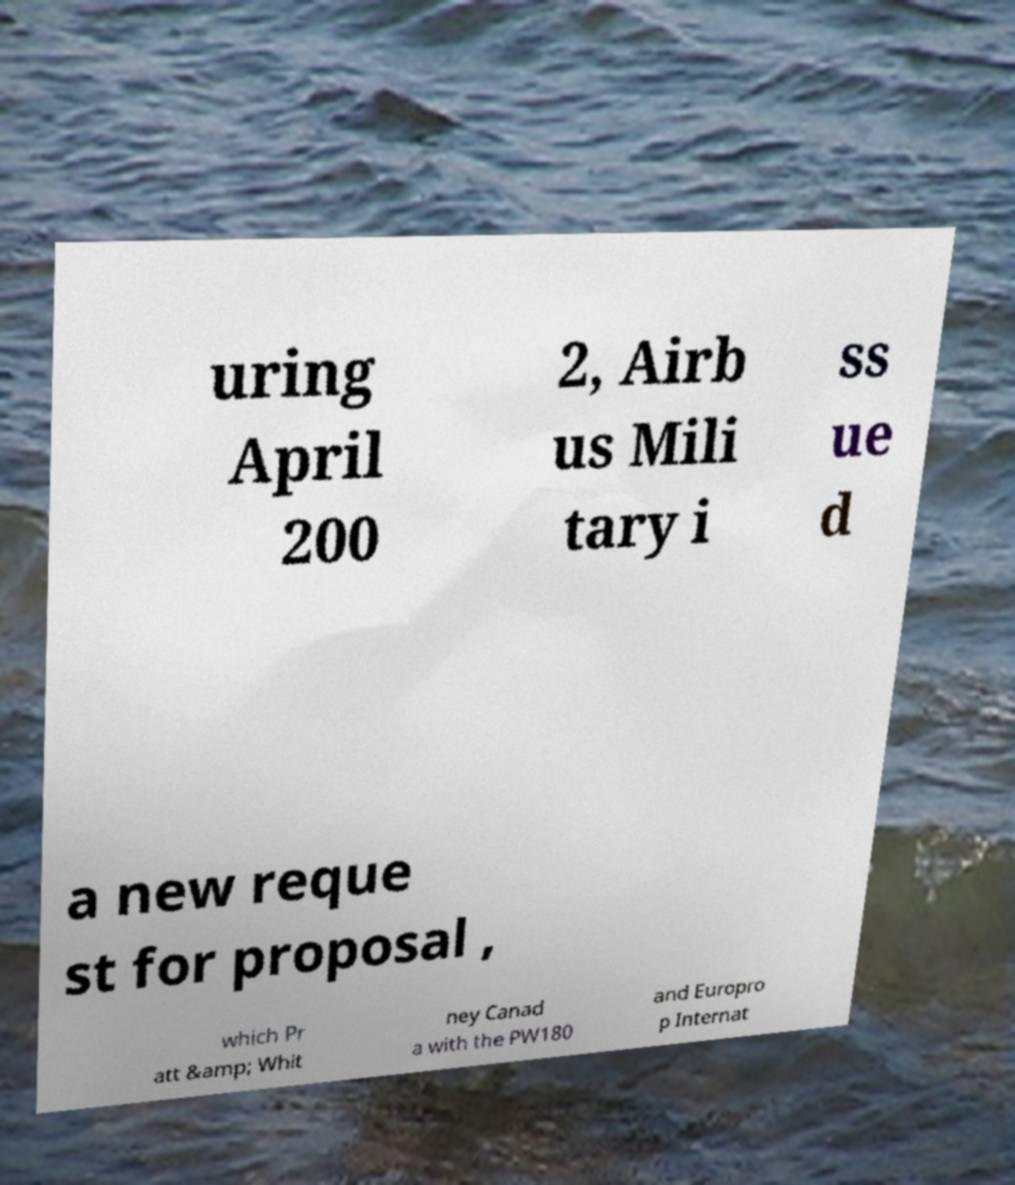Can you read and provide the text displayed in the image?This photo seems to have some interesting text. Can you extract and type it out for me? uring April 200 2, Airb us Mili tary i ss ue d a new reque st for proposal , which Pr att &amp; Whit ney Canad a with the PW180 and Europro p Internat 